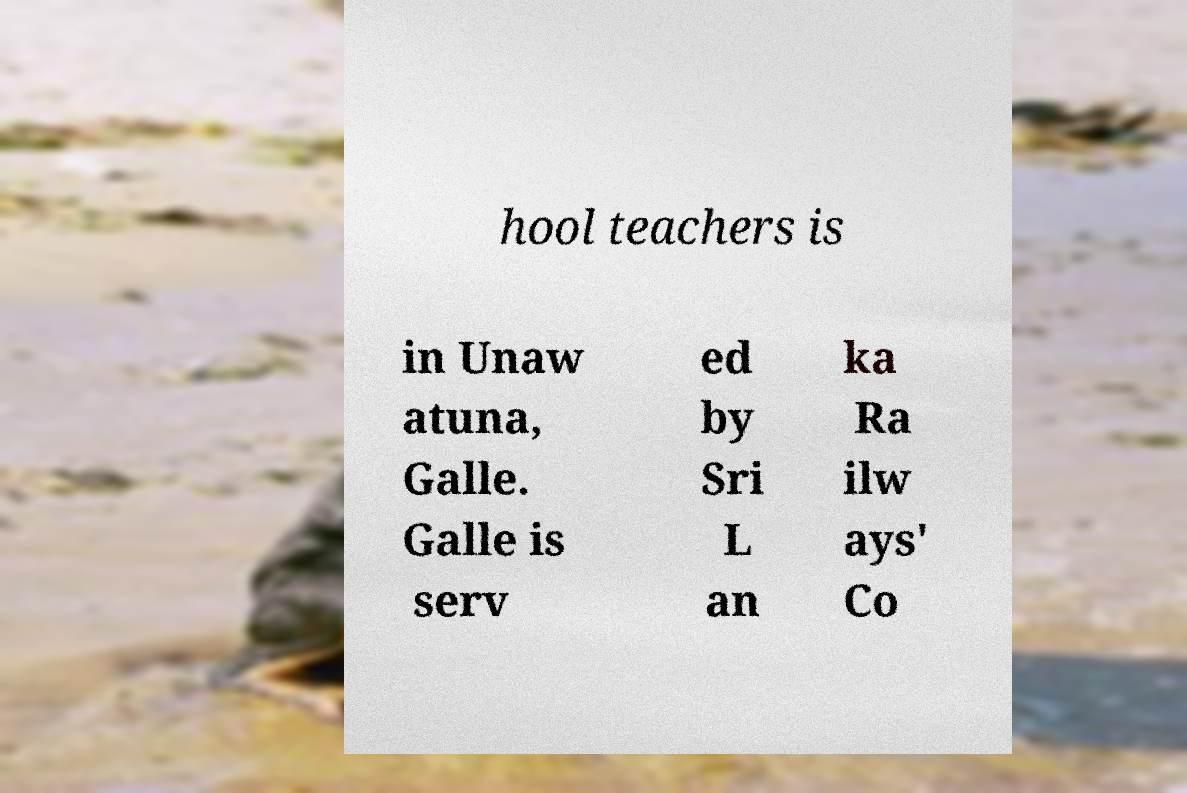For documentation purposes, I need the text within this image transcribed. Could you provide that? hool teachers is in Unaw atuna, Galle. Galle is serv ed by Sri L an ka Ra ilw ays' Co 